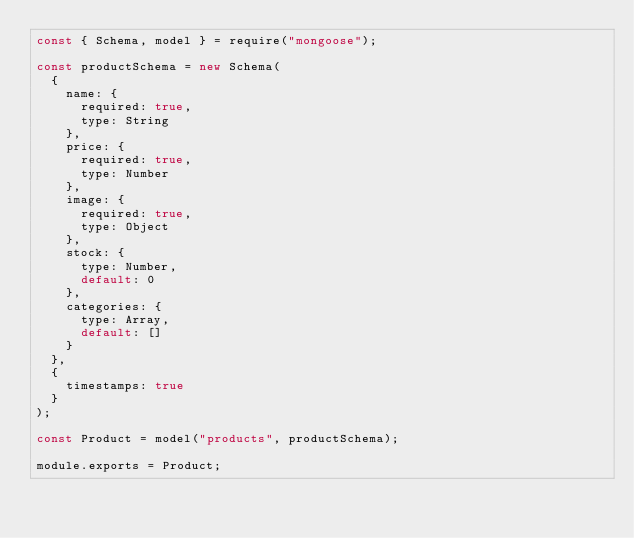<code> <loc_0><loc_0><loc_500><loc_500><_JavaScript_>const { Schema, model } = require("mongoose");

const productSchema = new Schema(
  {
    name: {
      required: true,
      type: String
    },
    price: {
      required: true,
      type: Number
    },
    image: {
      required: true,
      type: Object
    },
    stock: {
      type: Number,
      default: 0
    },
    categories: {
      type: Array,
      default: []
    }
  },
  {
    timestamps: true
  }
);

const Product = model("products", productSchema);

module.exports = Product;
</code> 